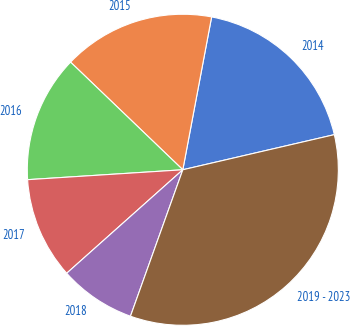Convert chart. <chart><loc_0><loc_0><loc_500><loc_500><pie_chart><fcel>2014<fcel>2015<fcel>2016<fcel>2017<fcel>2018<fcel>2019 - 2023<nl><fcel>18.41%<fcel>15.8%<fcel>13.18%<fcel>10.57%<fcel>7.95%<fcel>34.09%<nl></chart> 